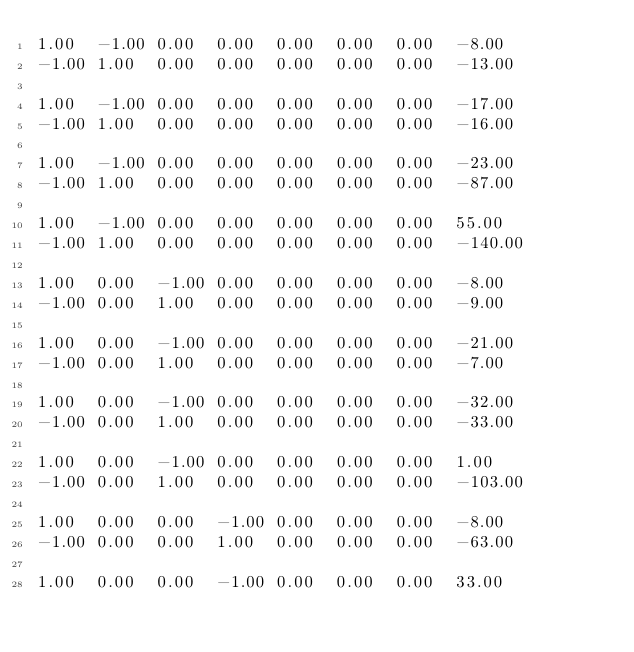Convert code to text. <code><loc_0><loc_0><loc_500><loc_500><_Matlab_>1.00	-1.00	0.00	0.00	0.00	0.00	0.00	-8.00
-1.00	1.00	0.00	0.00	0.00	0.00	0.00	-13.00

1.00	-1.00	0.00	0.00	0.00	0.00	0.00	-17.00
-1.00	1.00	0.00	0.00	0.00	0.00	0.00	-16.00

1.00	-1.00	0.00	0.00	0.00	0.00	0.00	-23.00
-1.00	1.00	0.00	0.00	0.00	0.00	0.00	-87.00

1.00	-1.00	0.00	0.00	0.00	0.00	0.00	55.00
-1.00	1.00	0.00	0.00	0.00	0.00	0.00	-140.00

1.00	0.00	-1.00	0.00	0.00	0.00	0.00	-8.00
-1.00	0.00	1.00	0.00	0.00	0.00	0.00	-9.00

1.00	0.00	-1.00	0.00	0.00	0.00	0.00	-21.00
-1.00	0.00	1.00	0.00	0.00	0.00	0.00	-7.00

1.00	0.00	-1.00	0.00	0.00	0.00	0.00	-32.00
-1.00	0.00	1.00	0.00	0.00	0.00	0.00	-33.00

1.00	0.00	-1.00	0.00	0.00	0.00	0.00	1.00
-1.00	0.00	1.00	0.00	0.00	0.00	0.00	-103.00

1.00	0.00	0.00	-1.00	0.00	0.00	0.00	-8.00
-1.00	0.00	0.00	1.00	0.00	0.00	0.00	-63.00

1.00	0.00	0.00	-1.00	0.00	0.00	0.00	33.00</code> 